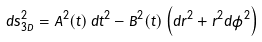<formula> <loc_0><loc_0><loc_500><loc_500>d s ^ { 2 } _ { 3 D } = A ^ { 2 } ( t ) \, d t ^ { 2 } - B ^ { 2 } ( t ) \left ( d r ^ { 2 } + r ^ { 2 } d \phi ^ { 2 } \right )</formula> 